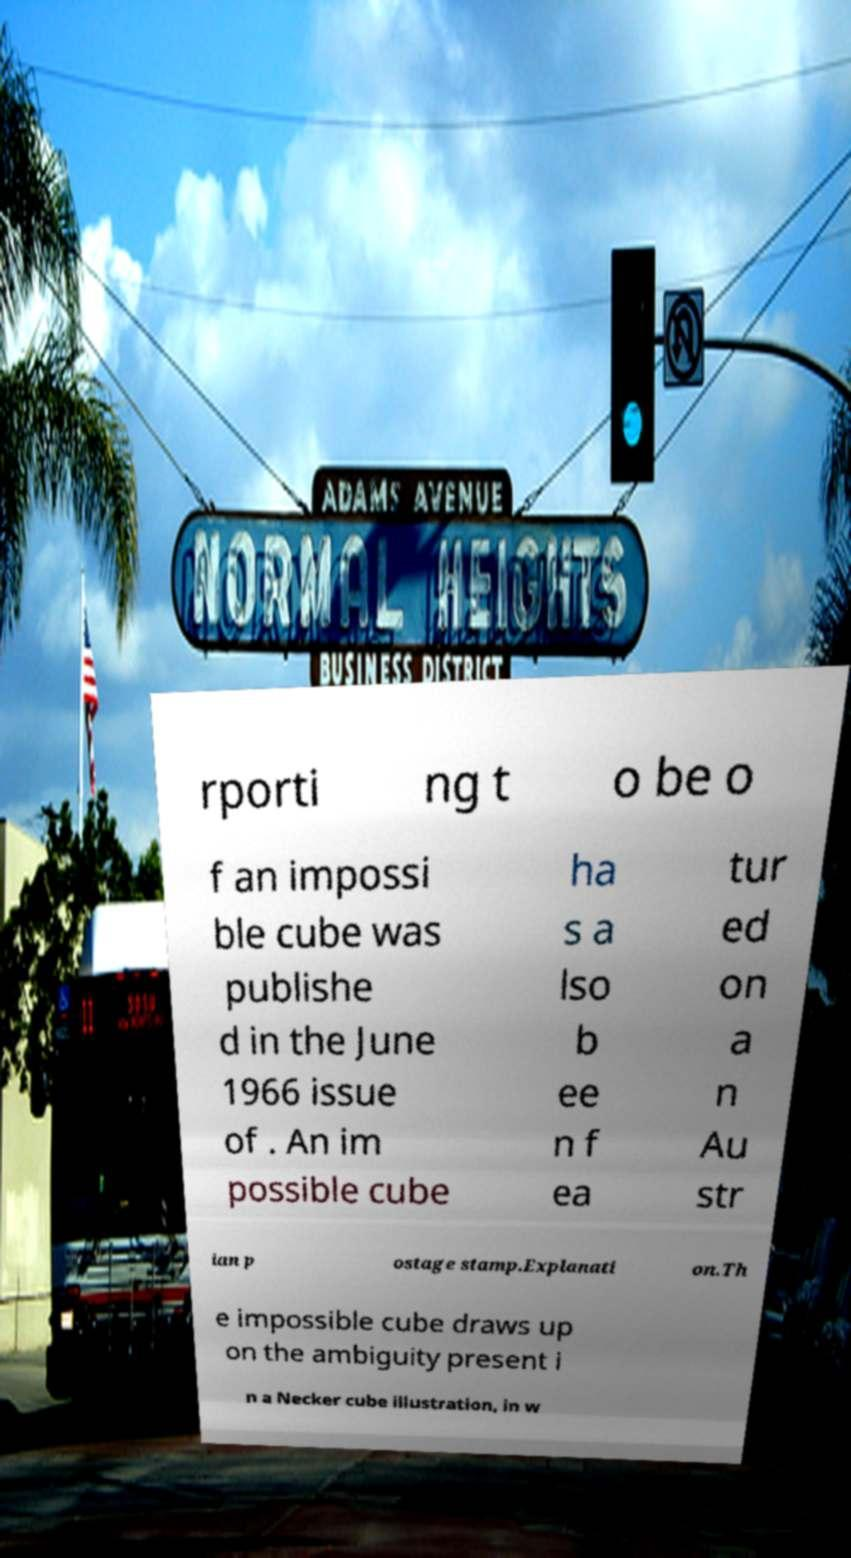Can you read and provide the text displayed in the image?This photo seems to have some interesting text. Can you extract and type it out for me? rporti ng t o be o f an impossi ble cube was publishe d in the June 1966 issue of . An im possible cube ha s a lso b ee n f ea tur ed on a n Au str ian p ostage stamp.Explanati on.Th e impossible cube draws up on the ambiguity present i n a Necker cube illustration, in w 